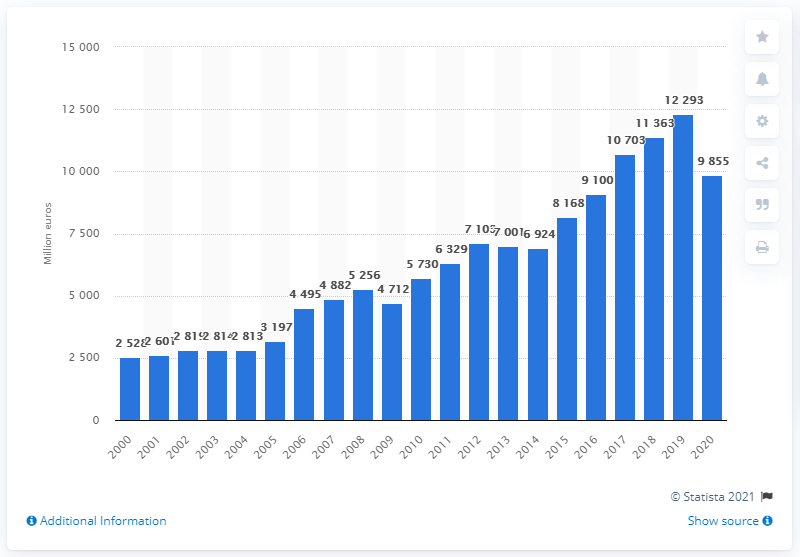Outline some significant characteristics in this image. The adidas Group's gross profit in 2020 was 9855. In 2019, the gross profit of the adidas Group was 12,293. 